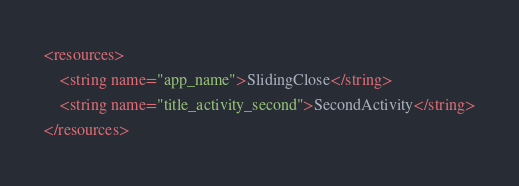<code> <loc_0><loc_0><loc_500><loc_500><_XML_><resources>
    <string name="app_name">SlidingClose</string>
    <string name="title_activity_second">SecondActivity</string>
</resources>
</code> 